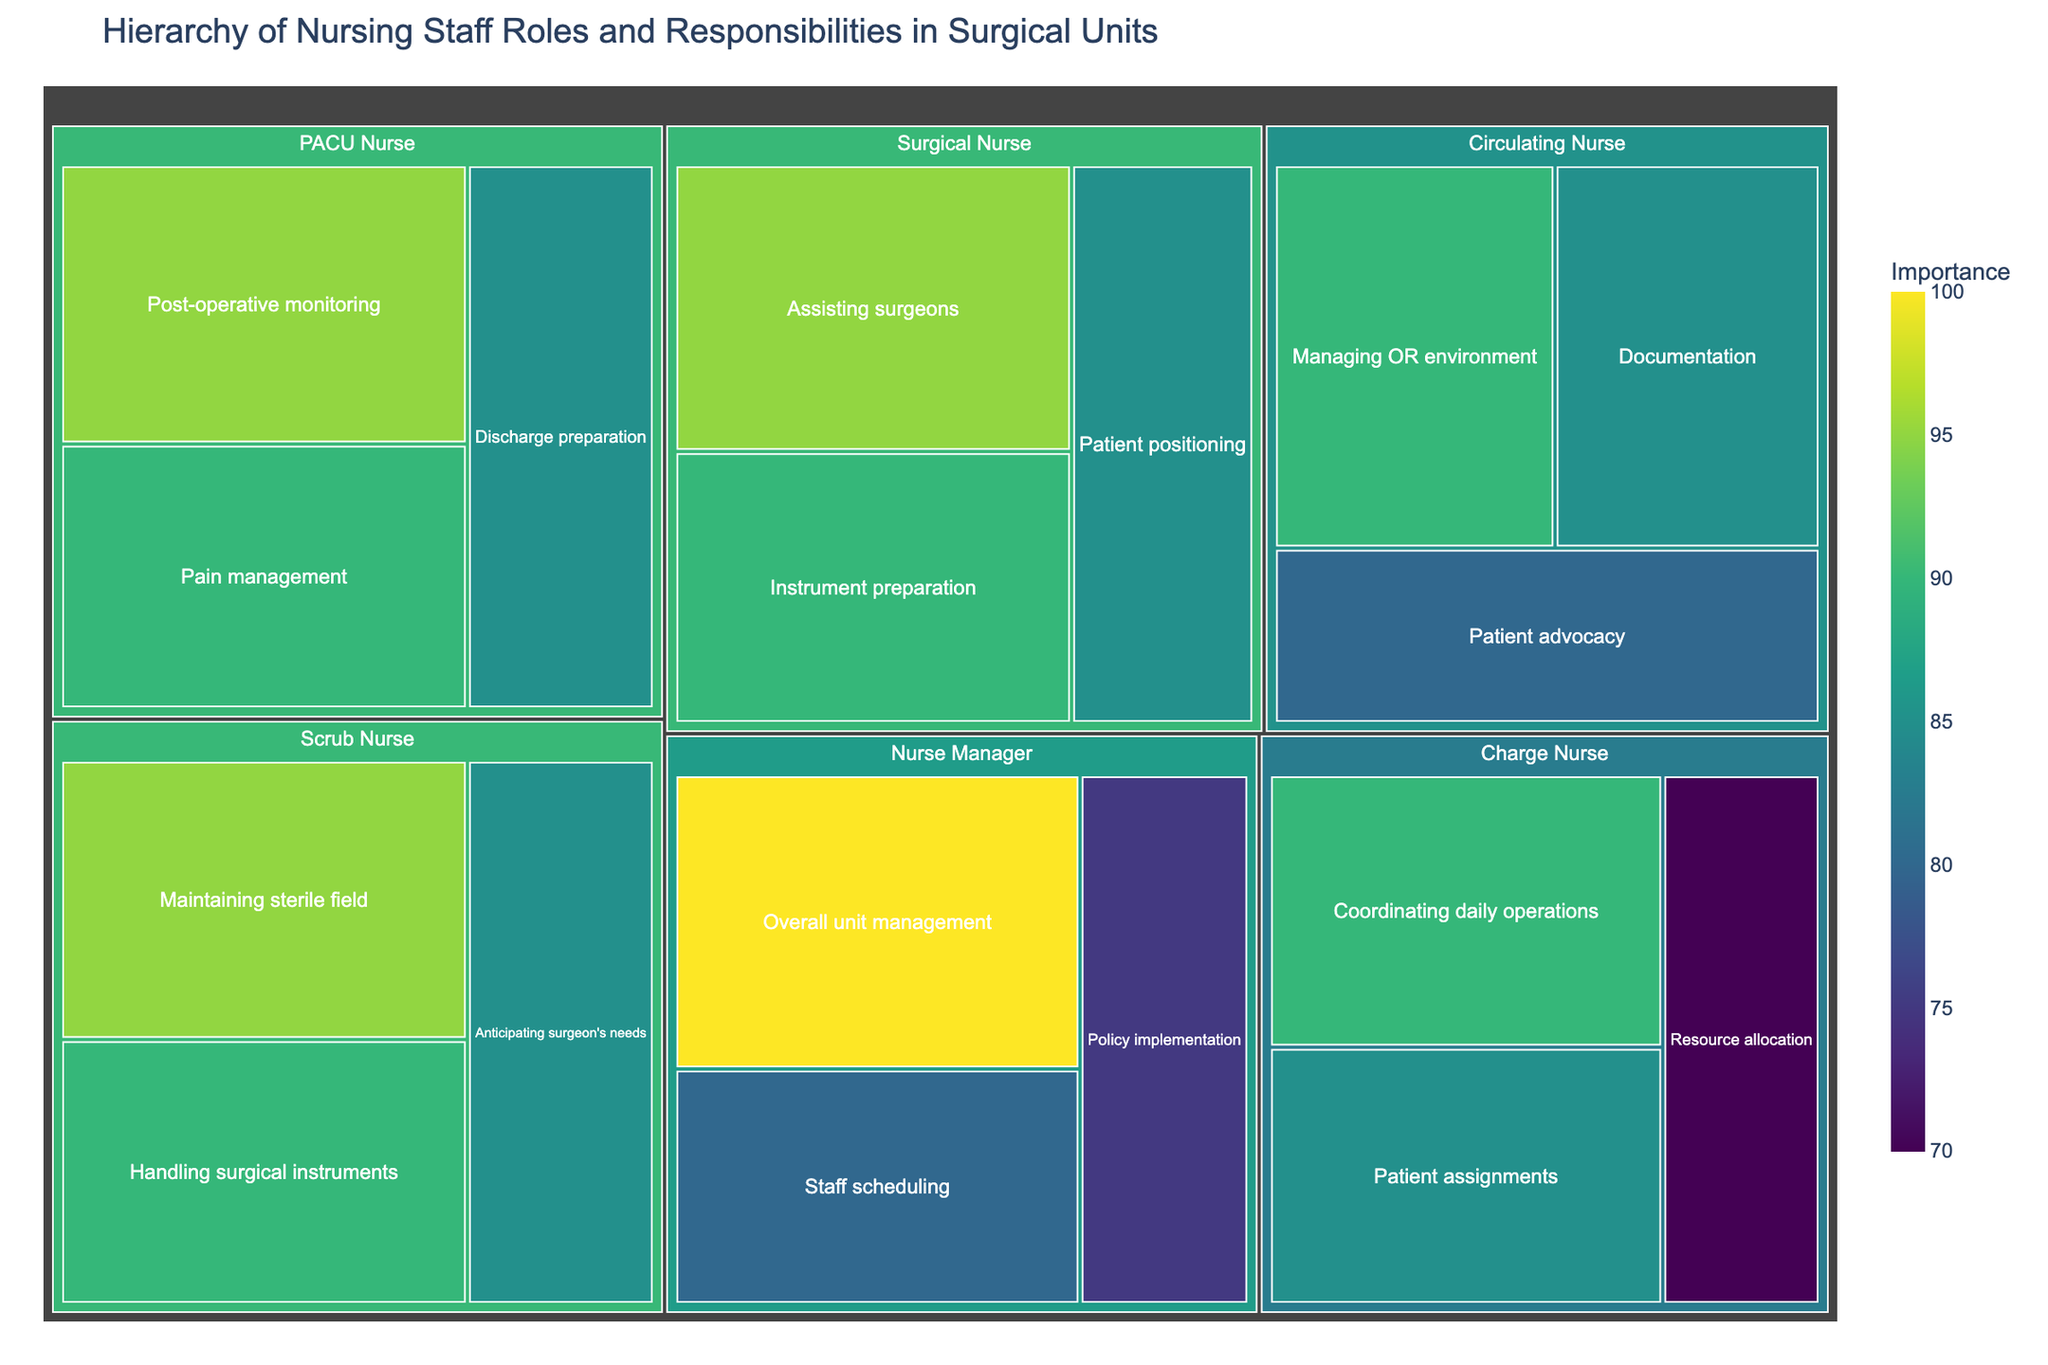What is the title of the treemap? The title can be found at the top of the treemap, serving as an introductory description.
Answer: Hierarchy of Nursing Staff Roles and Responsibilities in Surgical Units Which role has the highest level of importance for "Overall unit management"? The area and color intensity indicate that the Nurse Manager role is linked to "Overall unit management." All roles have unique responsibilities, and this one highlights its highest importance.
Answer: Nurse Manager What are the three responsibilities of the Surgical Nurse with their importance values? By examining the treemap, you can find "Surgical Nurse," and its branches display the three responsibilities and their importance values.
Answer: Assisting surgeons (95), Instrument preparation (90), Patient positioning (85) Who is responsible for "Discharge preparation" and what is its importance? Navigating through the treemap structure reveals "Discharge preparation" under the PACU Nurse, along with its importance value.
Answer: PACU Nurse, 85 Compare the importance of "Documentation" versus "Patient advocacy" for the Circulating Nurse. Which has a higher importance value? Locate the Circulating Nurse in the treemap and compare the areas labeled "Documentation" and "Patient advocacy" based on their color intensity and values.
Answer: Documentation (85), Patient advocacy (80), Documentation is higher Which role is connected with "Coordinating daily operations" and what is its importance value? Finding "Coordinating daily operations" in the treemap connects it to the Charge Nurse and shows its importance value.
Answer: Charge Nurse, 90 Calculate the sum of the importance values for all responsibilities of the Scrub Nurse. Locate "Scrub Nurse" in the treemap, then sum the importance values of its responsibilities: Maintaining sterile field (95), Handling surgical instruments (90), and Anticipating surgeon's needs (85).
Answer: 270 Which role has more responsibilities, Surgical Nurse or PACU Nurse? Identify the roles "Surgical Nurse" and "PACU Nurse" and count their respective responsibilities in the treemap.
Answer: Surgical Nurse (3 responsibilities), PACU Nurse (3 responsibilities), Both have the same number Which role involves "Policy implementation," and how does its importance compare to "Pain management"? Locate "Policy implementation" under Nurse Manager and "Pain management" under PACU Nurse in the treemap, then compare their importance values.
Answer: Nurse Manager (75), PACU Nurse (90), Pain management is more important What is the average importance value for responsibilities under Charge Nurse? Identify the responsibilities of the Charge Nurse in the treemap and calculate their average: (90 + 85 + 70) / 3.
Answer: 81.67 